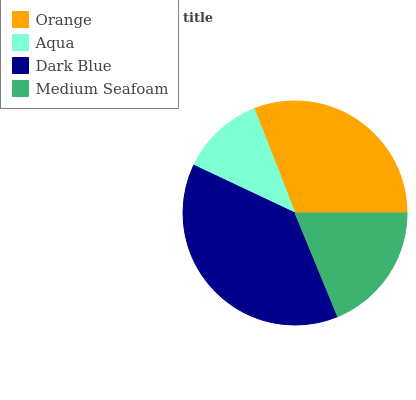Is Aqua the minimum?
Answer yes or no. Yes. Is Dark Blue the maximum?
Answer yes or no. Yes. Is Dark Blue the minimum?
Answer yes or no. No. Is Aqua the maximum?
Answer yes or no. No. Is Dark Blue greater than Aqua?
Answer yes or no. Yes. Is Aqua less than Dark Blue?
Answer yes or no. Yes. Is Aqua greater than Dark Blue?
Answer yes or no. No. Is Dark Blue less than Aqua?
Answer yes or no. No. Is Orange the high median?
Answer yes or no. Yes. Is Medium Seafoam the low median?
Answer yes or no. Yes. Is Dark Blue the high median?
Answer yes or no. No. Is Dark Blue the low median?
Answer yes or no. No. 